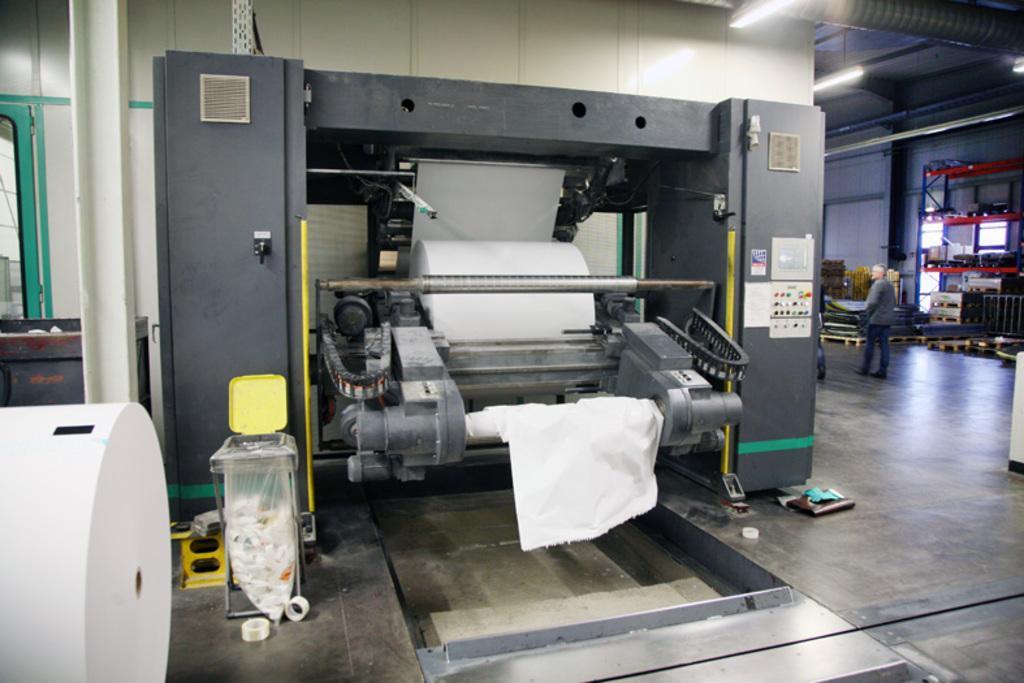Can you describe this image briefly? In this image there are machines. In the center there is a machine. There is a bundle of cloth in the machine. In front of the machine there is a table. There are a few objects in a cover. There are buttons beside the machine. Behind the machine there is a wall. There are tube lights hanging to the ceiling. To the right there is a man standing on the floor. 